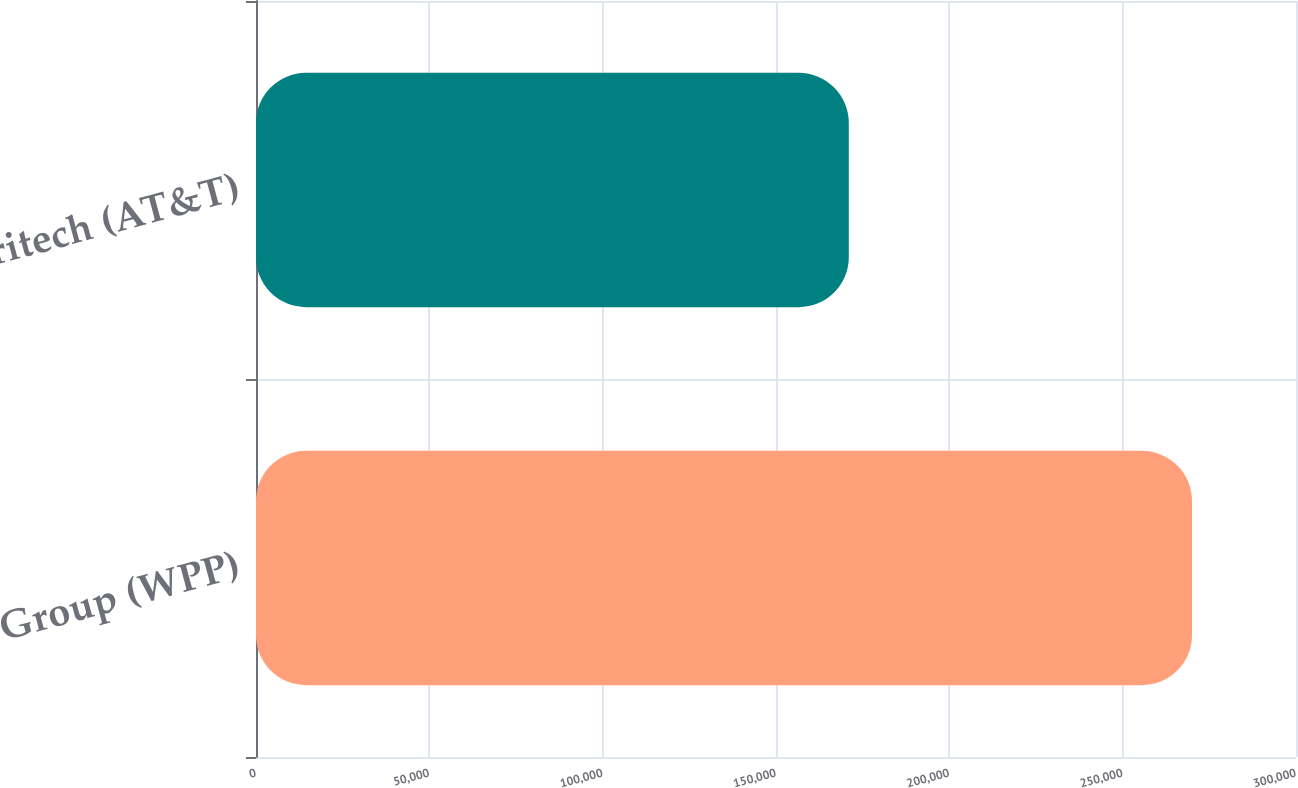Convert chart. <chart><loc_0><loc_0><loc_500><loc_500><bar_chart><fcel>Ogilvy Group (WPP)<fcel>Ameritech (AT&T)<nl><fcel>270000<fcel>171000<nl></chart> 